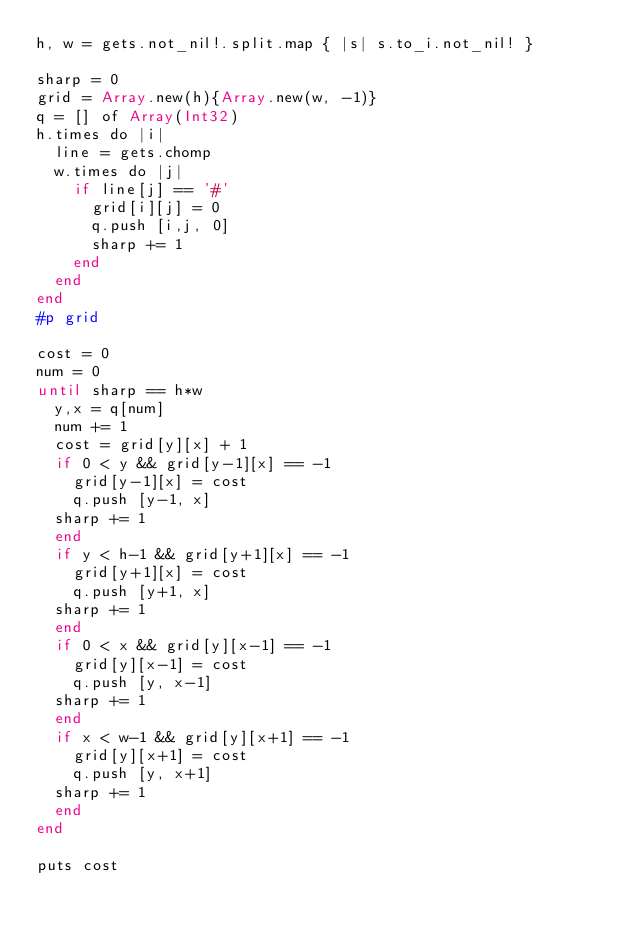<code> <loc_0><loc_0><loc_500><loc_500><_Crystal_>h, w = gets.not_nil!.split.map { |s| s.to_i.not_nil! }

sharp = 0
grid = Array.new(h){Array.new(w, -1)}
q = [] of Array(Int32)
h.times do |i|
  line = gets.chomp
  w.times do |j|
    if line[j] == '#'
      grid[i][j] = 0
      q.push [i,j, 0]
      sharp += 1
    end
  end
end
#p grid
 
cost = 0
num = 0
until sharp == h*w
  y,x = q[num]
  num += 1
  cost = grid[y][x] + 1
  if 0 < y && grid[y-1][x] == -1
    grid[y-1][x] = cost
    q.push [y-1, x]
  sharp += 1
  end
  if y < h-1 && grid[y+1][x] == -1
    grid[y+1][x] = cost
    q.push [y+1, x]
  sharp += 1
  end
  if 0 < x && grid[y][x-1] == -1
    grid[y][x-1] = cost
    q.push [y, x-1]
  sharp += 1
  end
  if x < w-1 && grid[y][x+1] == -1
    grid[y][x+1] = cost
    q.push [y, x+1]
  sharp += 1
  end
end
 
puts cost</code> 